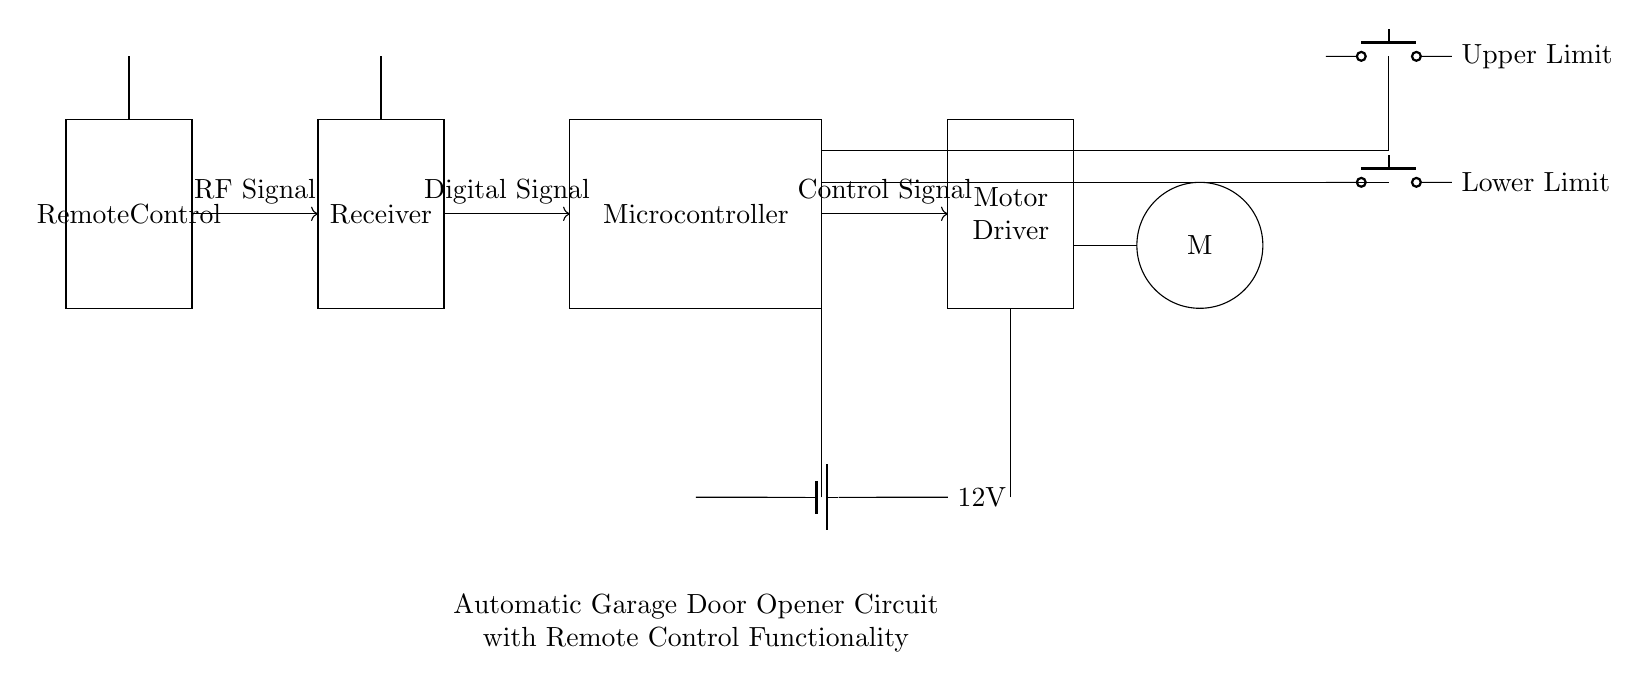What is the power supply voltage for this circuit? The power supply provides 12 volts, as indicated by the battery symbol connected at the bottom of the circuit diagram to the motor driver.
Answer: 12V What component generates the RF signals? The RF signals are generated by the remote control, depicted as a rectangle labeled 'Remote Control' at the left side of the circuit.
Answer: Remote Control What type of motor is used in this circuit? The motor used is a DC motor, which is represented by the circle labeled 'M' in the circuit diagram.
Answer: DC Motor What is the purpose of the limit switches in this circuit? The limit switches serve to detect the position of the garage door, preventing it from opening or closing beyond the designated limits, indicated by 'Upper Limit' and 'Lower Limit' in the diagram.
Answer: Detect position How does the receiver interact with the microcontroller? The receiver receives the RF signals from the remote control and converts them into a digital signal, which is then sent to the microcontroller to control the motor. This interaction is shown by the arrows connecting the receiver and microcontroller.
Answer: Converts signals What is the primary function of the microcontroller in this circuit? The microcontroller processes the digital signal from the receiver and sends control signals to the motor driver to operate the DC motor accordingly.
Answer: Process signals 